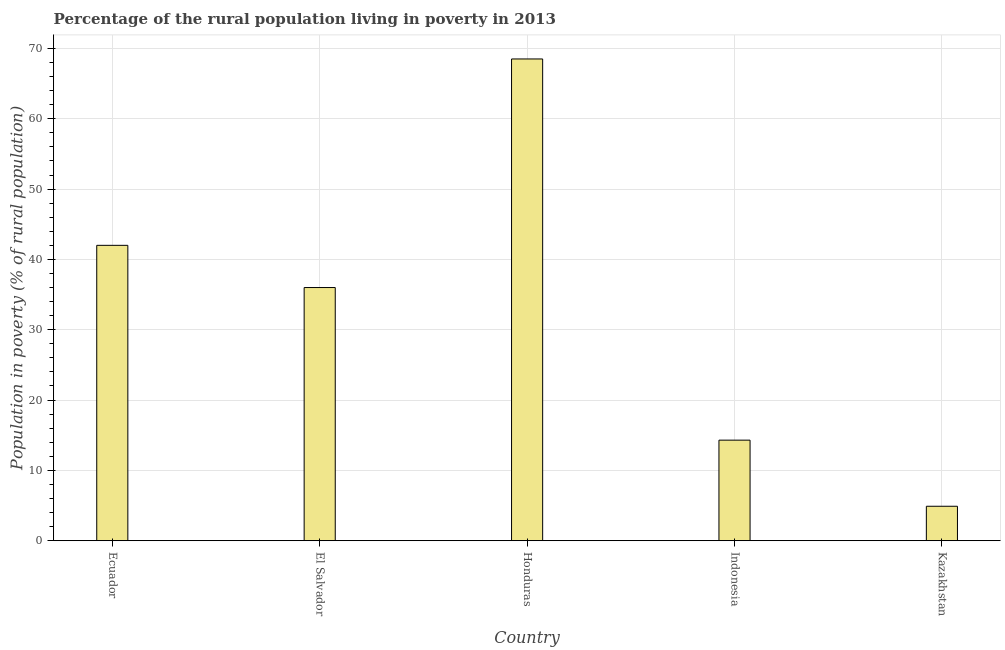Does the graph contain any zero values?
Ensure brevity in your answer.  No. Does the graph contain grids?
Your answer should be compact. Yes. What is the title of the graph?
Your answer should be very brief. Percentage of the rural population living in poverty in 2013. What is the label or title of the Y-axis?
Make the answer very short. Population in poverty (% of rural population). What is the percentage of rural population living below poverty line in Kazakhstan?
Your answer should be compact. 4.9. Across all countries, what is the maximum percentage of rural population living below poverty line?
Offer a very short reply. 68.5. In which country was the percentage of rural population living below poverty line maximum?
Your response must be concise. Honduras. In which country was the percentage of rural population living below poverty line minimum?
Provide a succinct answer. Kazakhstan. What is the sum of the percentage of rural population living below poverty line?
Ensure brevity in your answer.  165.7. What is the difference between the percentage of rural population living below poverty line in El Salvador and Kazakhstan?
Your answer should be very brief. 31.1. What is the average percentage of rural population living below poverty line per country?
Ensure brevity in your answer.  33.14. What is the median percentage of rural population living below poverty line?
Give a very brief answer. 36. What is the ratio of the percentage of rural population living below poverty line in Ecuador to that in El Salvador?
Keep it short and to the point. 1.17. Is the percentage of rural population living below poverty line in Ecuador less than that in Kazakhstan?
Provide a succinct answer. No. What is the difference between the highest and the second highest percentage of rural population living below poverty line?
Provide a succinct answer. 26.5. Is the sum of the percentage of rural population living below poverty line in Indonesia and Kazakhstan greater than the maximum percentage of rural population living below poverty line across all countries?
Your response must be concise. No. What is the difference between the highest and the lowest percentage of rural population living below poverty line?
Your answer should be very brief. 63.6. In how many countries, is the percentage of rural population living below poverty line greater than the average percentage of rural population living below poverty line taken over all countries?
Your response must be concise. 3. Are all the bars in the graph horizontal?
Your answer should be very brief. No. What is the difference between two consecutive major ticks on the Y-axis?
Your response must be concise. 10. What is the Population in poverty (% of rural population) of Ecuador?
Provide a succinct answer. 42. What is the Population in poverty (% of rural population) of El Salvador?
Offer a terse response. 36. What is the Population in poverty (% of rural population) in Honduras?
Provide a succinct answer. 68.5. What is the Population in poverty (% of rural population) of Kazakhstan?
Offer a very short reply. 4.9. What is the difference between the Population in poverty (% of rural population) in Ecuador and El Salvador?
Provide a short and direct response. 6. What is the difference between the Population in poverty (% of rural population) in Ecuador and Honduras?
Provide a short and direct response. -26.5. What is the difference between the Population in poverty (% of rural population) in Ecuador and Indonesia?
Make the answer very short. 27.7. What is the difference between the Population in poverty (% of rural population) in Ecuador and Kazakhstan?
Your answer should be very brief. 37.1. What is the difference between the Population in poverty (% of rural population) in El Salvador and Honduras?
Make the answer very short. -32.5. What is the difference between the Population in poverty (% of rural population) in El Salvador and Indonesia?
Ensure brevity in your answer.  21.7. What is the difference between the Population in poverty (% of rural population) in El Salvador and Kazakhstan?
Ensure brevity in your answer.  31.1. What is the difference between the Population in poverty (% of rural population) in Honduras and Indonesia?
Your answer should be compact. 54.2. What is the difference between the Population in poverty (% of rural population) in Honduras and Kazakhstan?
Keep it short and to the point. 63.6. What is the difference between the Population in poverty (% of rural population) in Indonesia and Kazakhstan?
Provide a short and direct response. 9.4. What is the ratio of the Population in poverty (% of rural population) in Ecuador to that in El Salvador?
Your response must be concise. 1.17. What is the ratio of the Population in poverty (% of rural population) in Ecuador to that in Honduras?
Provide a succinct answer. 0.61. What is the ratio of the Population in poverty (% of rural population) in Ecuador to that in Indonesia?
Make the answer very short. 2.94. What is the ratio of the Population in poverty (% of rural population) in Ecuador to that in Kazakhstan?
Offer a very short reply. 8.57. What is the ratio of the Population in poverty (% of rural population) in El Salvador to that in Honduras?
Provide a succinct answer. 0.53. What is the ratio of the Population in poverty (% of rural population) in El Salvador to that in Indonesia?
Your answer should be very brief. 2.52. What is the ratio of the Population in poverty (% of rural population) in El Salvador to that in Kazakhstan?
Your answer should be very brief. 7.35. What is the ratio of the Population in poverty (% of rural population) in Honduras to that in Indonesia?
Keep it short and to the point. 4.79. What is the ratio of the Population in poverty (% of rural population) in Honduras to that in Kazakhstan?
Provide a succinct answer. 13.98. What is the ratio of the Population in poverty (% of rural population) in Indonesia to that in Kazakhstan?
Provide a succinct answer. 2.92. 